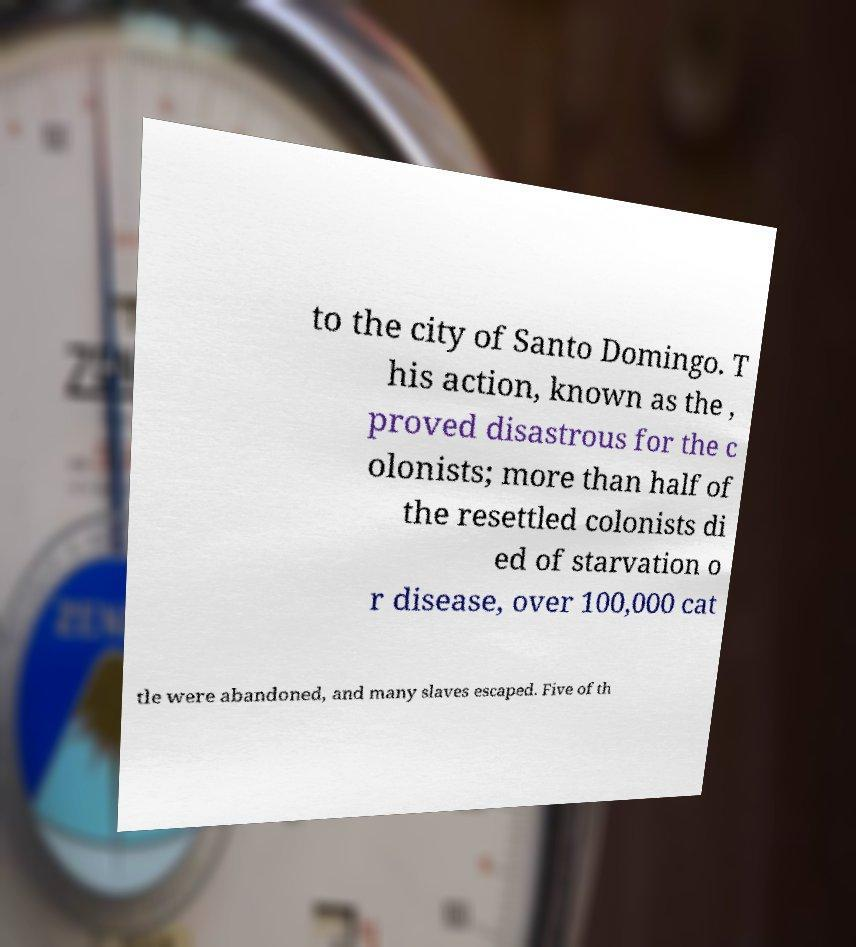Could you assist in decoding the text presented in this image and type it out clearly? to the city of Santo Domingo. T his action, known as the , proved disastrous for the c olonists; more than half of the resettled colonists di ed of starvation o r disease, over 100,000 cat tle were abandoned, and many slaves escaped. Five of th 